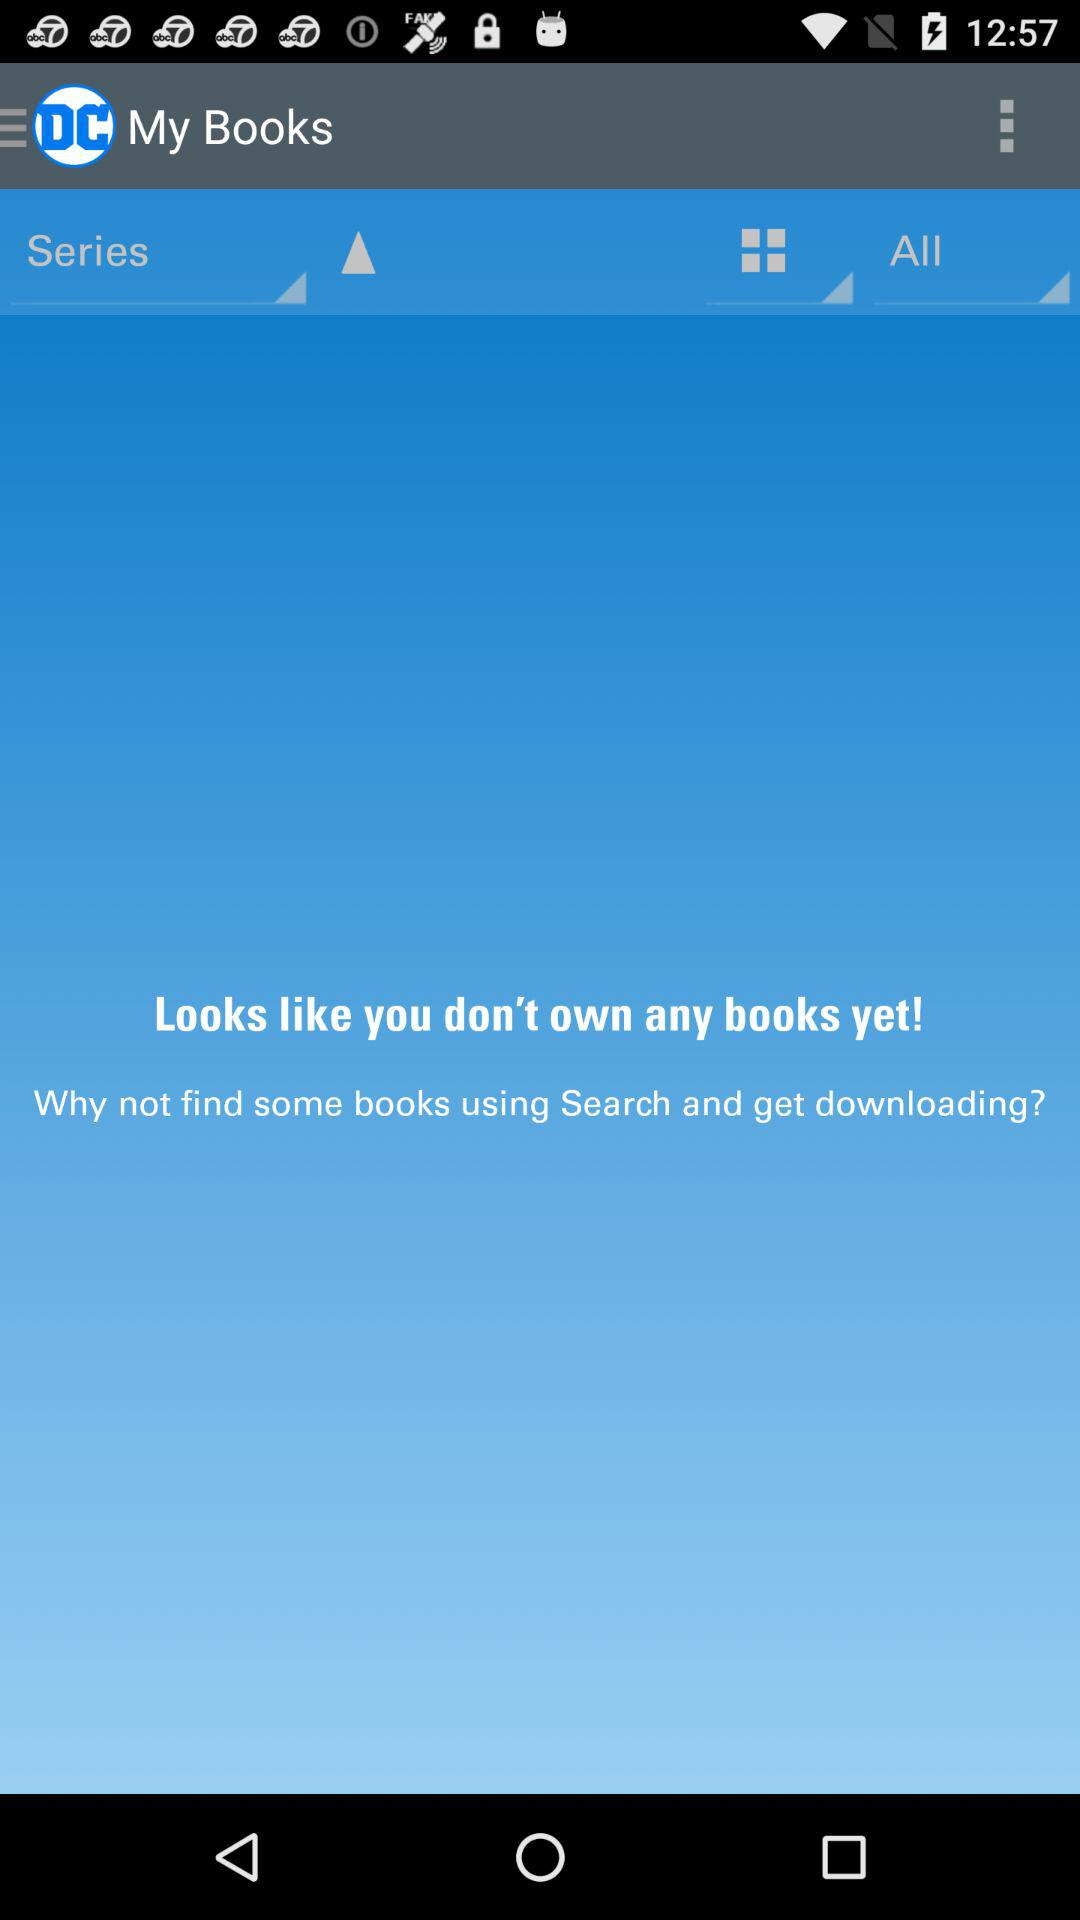How many books do I own?
Answer the question using a single word or phrase. 0 